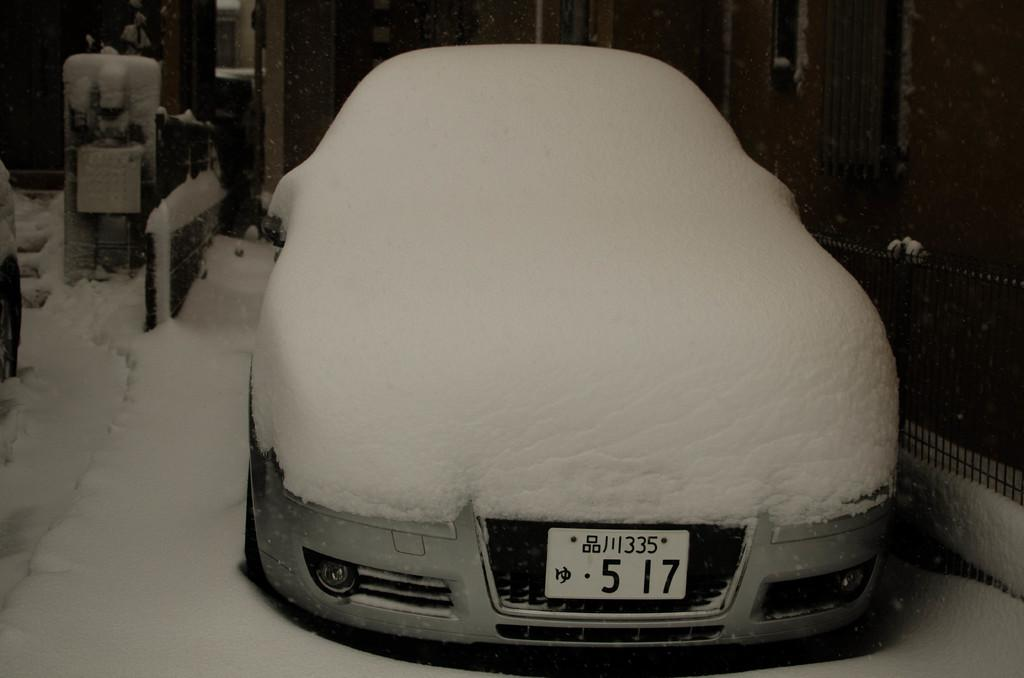<image>
Describe the image concisely. a car that has the numbers 517 on it 